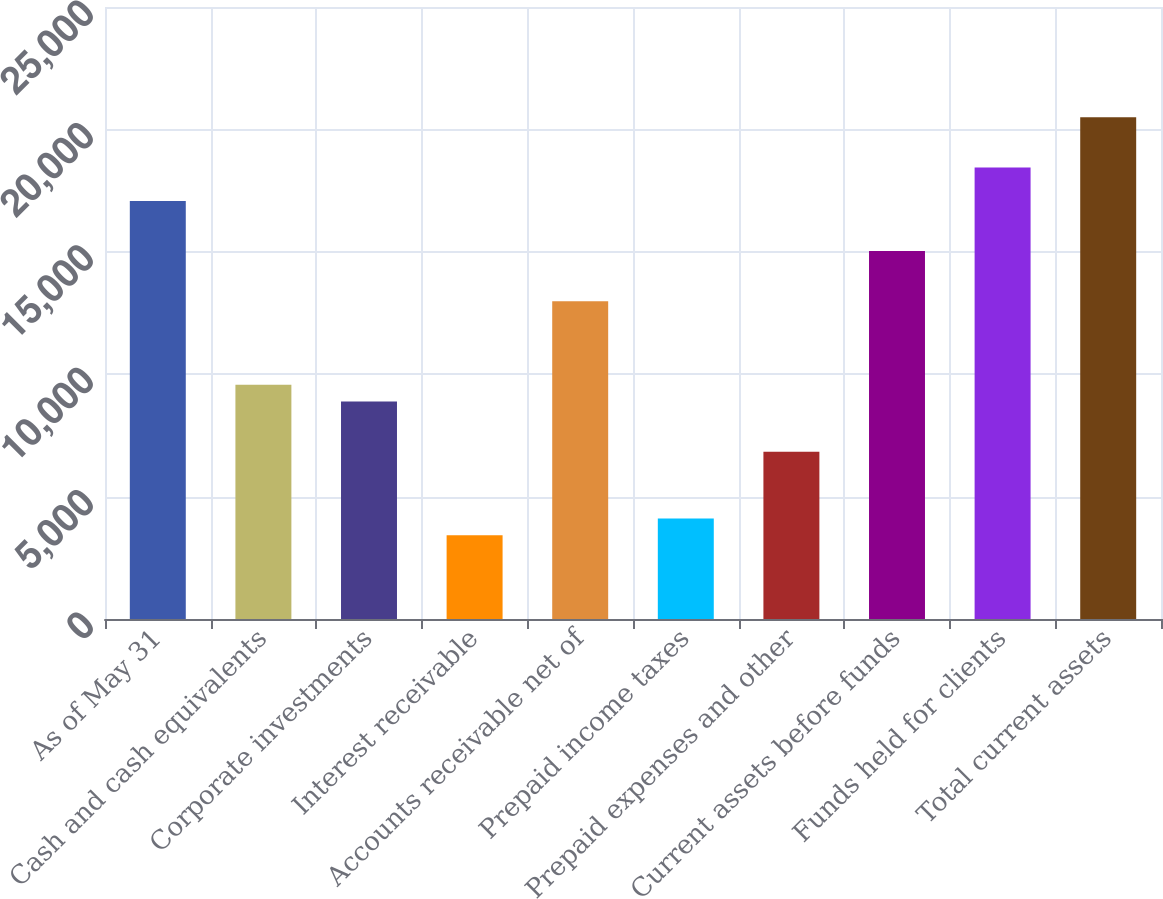Convert chart to OTSL. <chart><loc_0><loc_0><loc_500><loc_500><bar_chart><fcel>As of May 31<fcel>Cash and cash equivalents<fcel>Corporate investments<fcel>Interest receivable<fcel>Accounts receivable net of<fcel>Prepaid income taxes<fcel>Prepaid expenses and other<fcel>Current assets before funds<fcel>Funds held for clients<fcel>Total current assets<nl><fcel>17078.8<fcel>9565.74<fcel>8882.73<fcel>3418.65<fcel>12980.8<fcel>4101.66<fcel>6833.7<fcel>15029.8<fcel>18444.9<fcel>20493.9<nl></chart> 